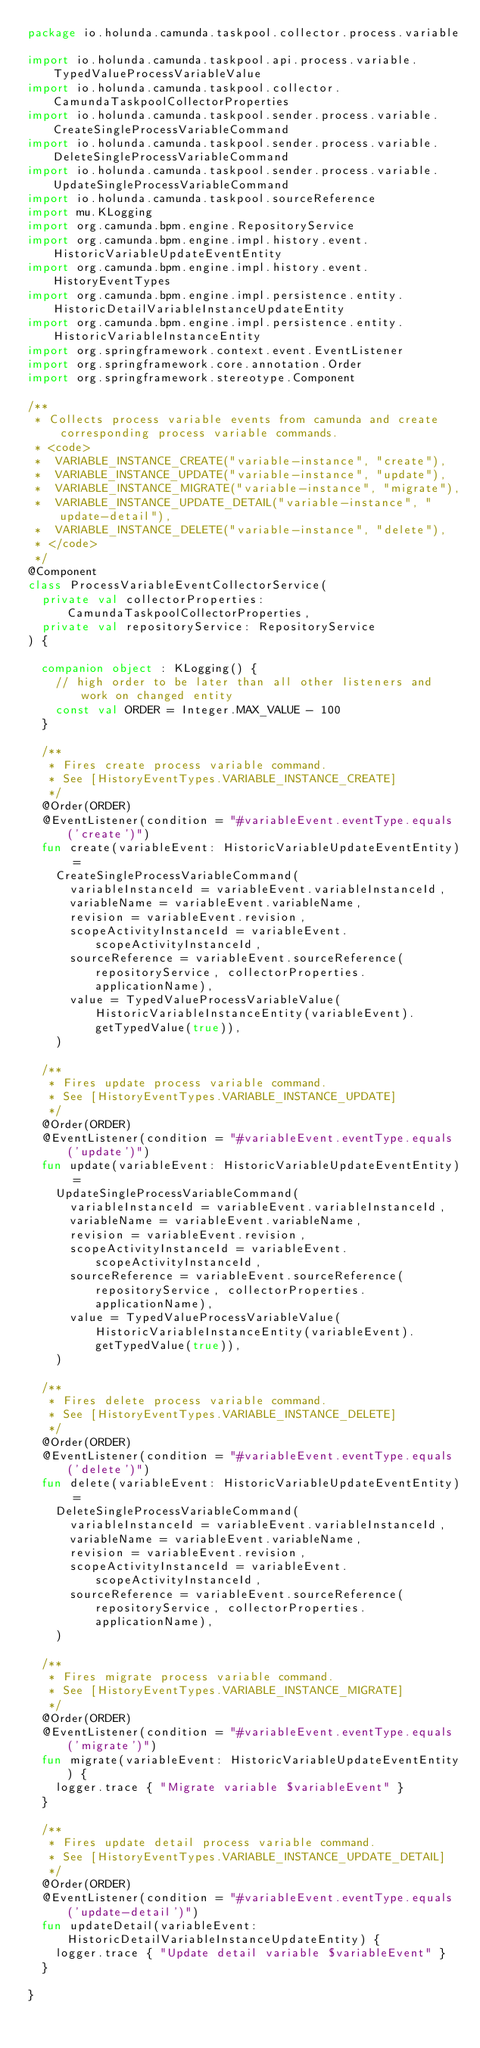Convert code to text. <code><loc_0><loc_0><loc_500><loc_500><_Kotlin_>package io.holunda.camunda.taskpool.collector.process.variable

import io.holunda.camunda.taskpool.api.process.variable.TypedValueProcessVariableValue
import io.holunda.camunda.taskpool.collector.CamundaTaskpoolCollectorProperties
import io.holunda.camunda.taskpool.sender.process.variable.CreateSingleProcessVariableCommand
import io.holunda.camunda.taskpool.sender.process.variable.DeleteSingleProcessVariableCommand
import io.holunda.camunda.taskpool.sender.process.variable.UpdateSingleProcessVariableCommand
import io.holunda.camunda.taskpool.sourceReference
import mu.KLogging
import org.camunda.bpm.engine.RepositoryService
import org.camunda.bpm.engine.impl.history.event.HistoricVariableUpdateEventEntity
import org.camunda.bpm.engine.impl.history.event.HistoryEventTypes
import org.camunda.bpm.engine.impl.persistence.entity.HistoricDetailVariableInstanceUpdateEntity
import org.camunda.bpm.engine.impl.persistence.entity.HistoricVariableInstanceEntity
import org.springframework.context.event.EventListener
import org.springframework.core.annotation.Order
import org.springframework.stereotype.Component

/**
 * Collects process variable events from camunda and create corresponding process variable commands.
 * <code>
 *  VARIABLE_INSTANCE_CREATE("variable-instance", "create"),
 *  VARIABLE_INSTANCE_UPDATE("variable-instance", "update"),
 *  VARIABLE_INSTANCE_MIGRATE("variable-instance", "migrate"),
 *  VARIABLE_INSTANCE_UPDATE_DETAIL("variable-instance", "update-detail"),
 *  VARIABLE_INSTANCE_DELETE("variable-instance", "delete"),
 * </code>
 */
@Component
class ProcessVariableEventCollectorService(
  private val collectorProperties: CamundaTaskpoolCollectorProperties,
  private val repositoryService: RepositoryService
) {

  companion object : KLogging() {
    // high order to be later than all other listeners and work on changed entity
    const val ORDER = Integer.MAX_VALUE - 100
  }

  /**
   * Fires create process variable command.
   * See [HistoryEventTypes.VARIABLE_INSTANCE_CREATE]
   */
  @Order(ORDER)
  @EventListener(condition = "#variableEvent.eventType.equals('create')")
  fun create(variableEvent: HistoricVariableUpdateEventEntity) =
    CreateSingleProcessVariableCommand(
      variableInstanceId = variableEvent.variableInstanceId,
      variableName = variableEvent.variableName,
      revision = variableEvent.revision,
      scopeActivityInstanceId = variableEvent.scopeActivityInstanceId,
      sourceReference = variableEvent.sourceReference(repositoryService, collectorProperties.applicationName),
      value = TypedValueProcessVariableValue(HistoricVariableInstanceEntity(variableEvent).getTypedValue(true)),
    )

  /**
   * Fires update process variable command.
   * See [HistoryEventTypes.VARIABLE_INSTANCE_UPDATE]
   */
  @Order(ORDER)
  @EventListener(condition = "#variableEvent.eventType.equals('update')")
  fun update(variableEvent: HistoricVariableUpdateEventEntity) =
    UpdateSingleProcessVariableCommand(
      variableInstanceId = variableEvent.variableInstanceId,
      variableName = variableEvent.variableName,
      revision = variableEvent.revision,
      scopeActivityInstanceId = variableEvent.scopeActivityInstanceId,
      sourceReference = variableEvent.sourceReference(repositoryService, collectorProperties.applicationName),
      value = TypedValueProcessVariableValue(HistoricVariableInstanceEntity(variableEvent).getTypedValue(true)),
    )

  /**
   * Fires delete process variable command.
   * See [HistoryEventTypes.VARIABLE_INSTANCE_DELETE]
   */
  @Order(ORDER)
  @EventListener(condition = "#variableEvent.eventType.equals('delete')")
  fun delete(variableEvent: HistoricVariableUpdateEventEntity) =
    DeleteSingleProcessVariableCommand(
      variableInstanceId = variableEvent.variableInstanceId,
      variableName = variableEvent.variableName,
      revision = variableEvent.revision,
      scopeActivityInstanceId = variableEvent.scopeActivityInstanceId,
      sourceReference = variableEvent.sourceReference(repositoryService, collectorProperties.applicationName),
    )

  /**
   * Fires migrate process variable command.
   * See [HistoryEventTypes.VARIABLE_INSTANCE_MIGRATE]
   */
  @Order(ORDER)
  @EventListener(condition = "#variableEvent.eventType.equals('migrate')")
  fun migrate(variableEvent: HistoricVariableUpdateEventEntity) {
    logger.trace { "Migrate variable $variableEvent" }
  }

  /**
   * Fires update detail process variable command.
   * See [HistoryEventTypes.VARIABLE_INSTANCE_UPDATE_DETAIL]
   */
  @Order(ORDER)
  @EventListener(condition = "#variableEvent.eventType.equals('update-detail')")
  fun updateDetail(variableEvent: HistoricDetailVariableInstanceUpdateEntity) {
    logger.trace { "Update detail variable $variableEvent" }
  }

}

</code> 